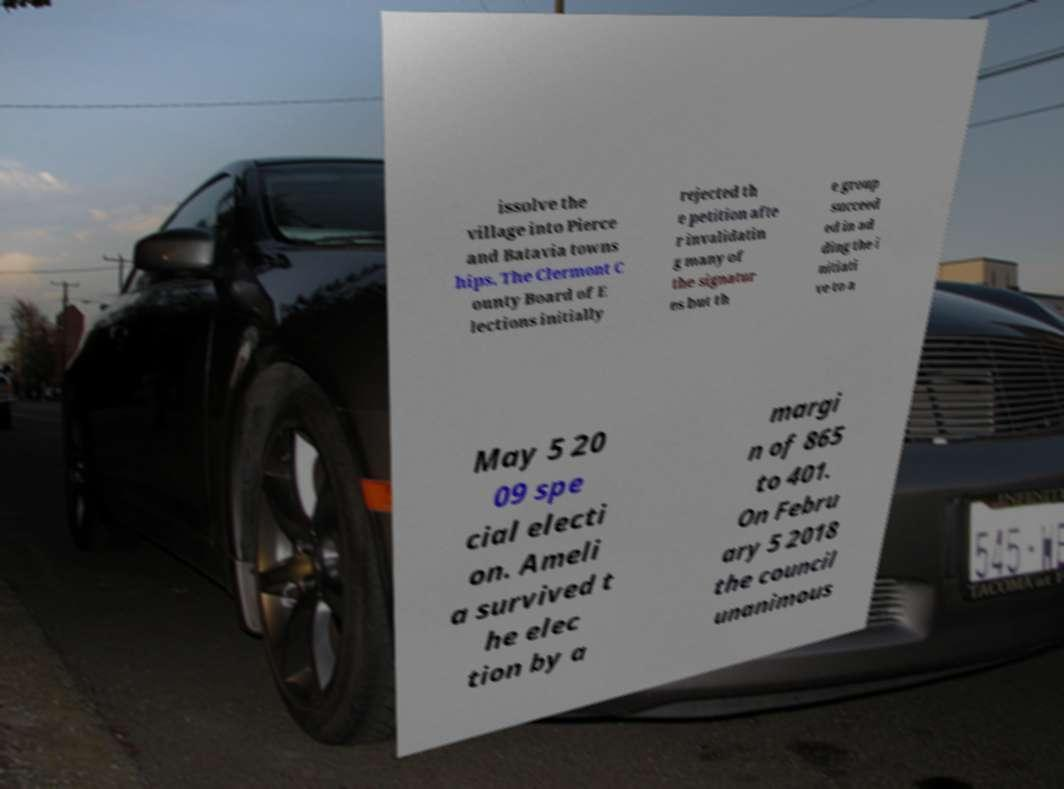Could you extract and type out the text from this image? issolve the village into Pierce and Batavia towns hips. The Clermont C ounty Board of E lections initially rejected th e petition afte r invalidatin g many of the signatur es but th e group succeed ed in ad ding the i nitiati ve to a May 5 20 09 spe cial electi on. Ameli a survived t he elec tion by a margi n of 865 to 401. On Febru ary 5 2018 the council unanimous 